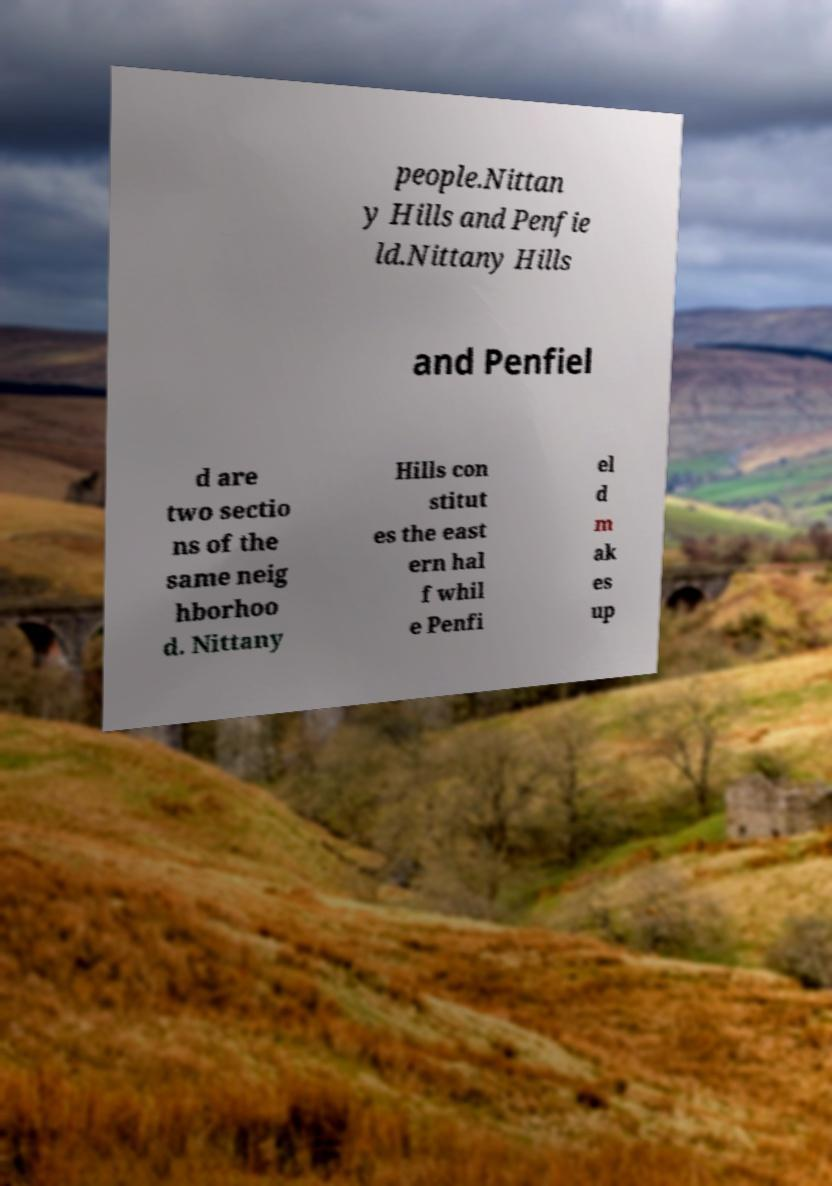I need the written content from this picture converted into text. Can you do that? people.Nittan y Hills and Penfie ld.Nittany Hills and Penfiel d are two sectio ns of the same neig hborhoo d. Nittany Hills con stitut es the east ern hal f whil e Penfi el d m ak es up 